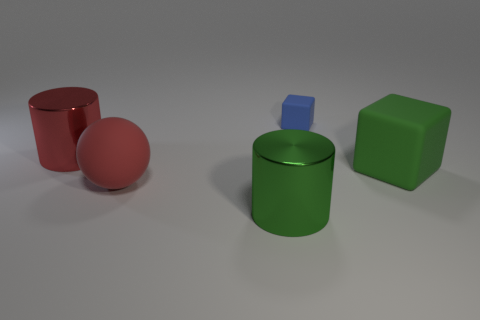Add 4 large red rubber balls. How many objects exist? 9 Subtract all cubes. How many objects are left? 3 Subtract 1 cylinders. How many cylinders are left? 1 Subtract all purple cylinders. Subtract all purple blocks. How many cylinders are left? 2 Subtract all brown cylinders. How many blue cubes are left? 1 Subtract all blue matte balls. Subtract all large cylinders. How many objects are left? 3 Add 5 large spheres. How many large spheres are left? 6 Add 4 large things. How many large things exist? 8 Subtract 0 gray blocks. How many objects are left? 5 